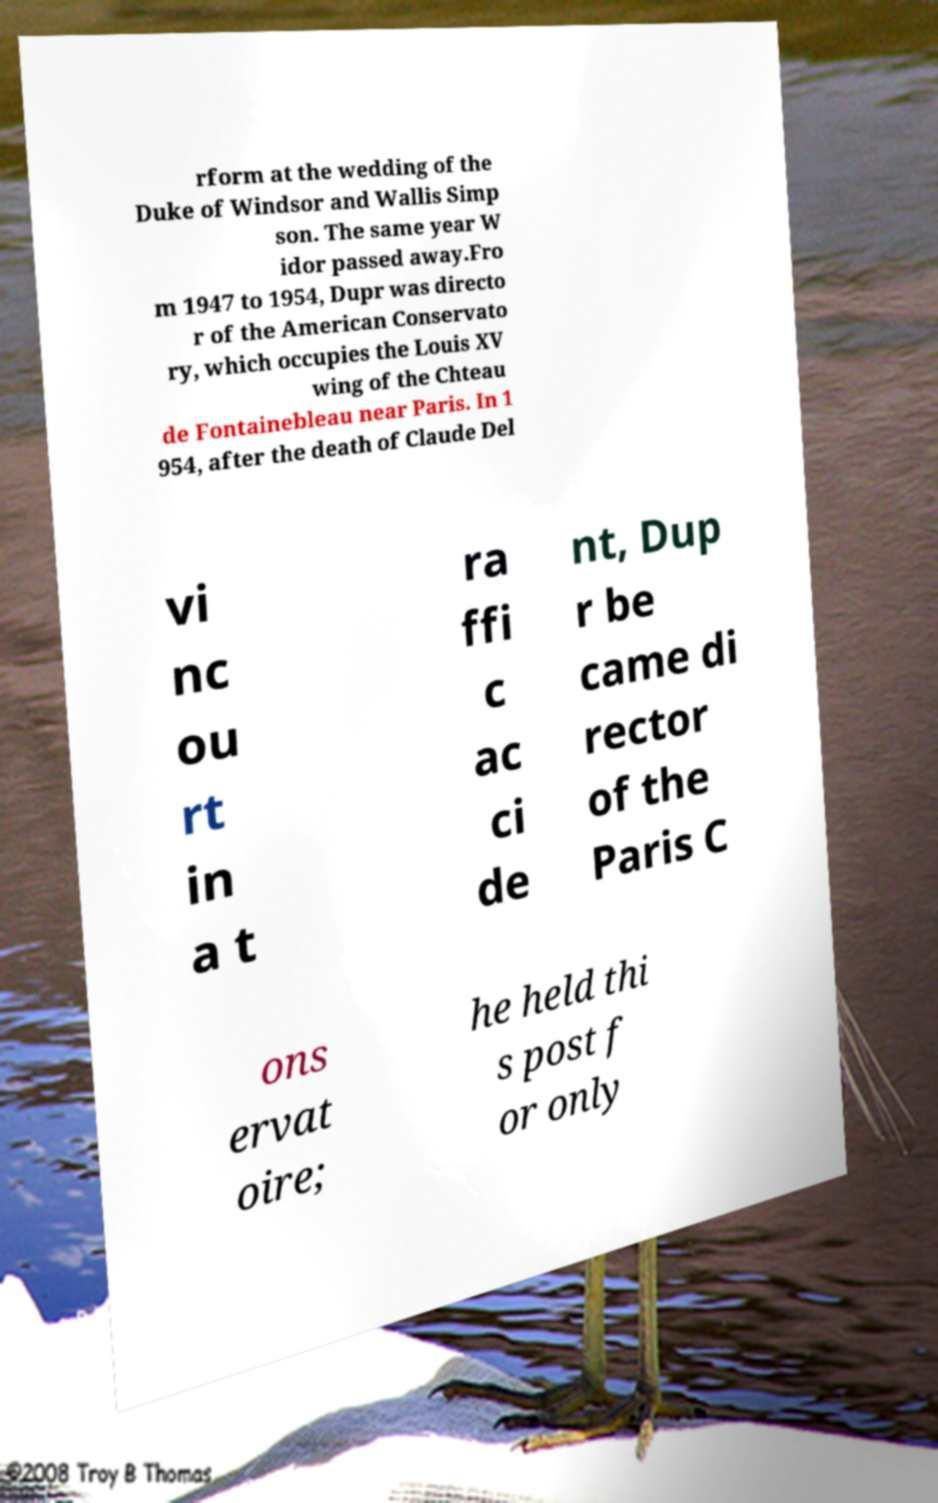What messages or text are displayed in this image? I need them in a readable, typed format. rform at the wedding of the Duke of Windsor and Wallis Simp son. The same year W idor passed away.Fro m 1947 to 1954, Dupr was directo r of the American Conservato ry, which occupies the Louis XV wing of the Chteau de Fontainebleau near Paris. In 1 954, after the death of Claude Del vi nc ou rt in a t ra ffi c ac ci de nt, Dup r be came di rector of the Paris C ons ervat oire; he held thi s post f or only 